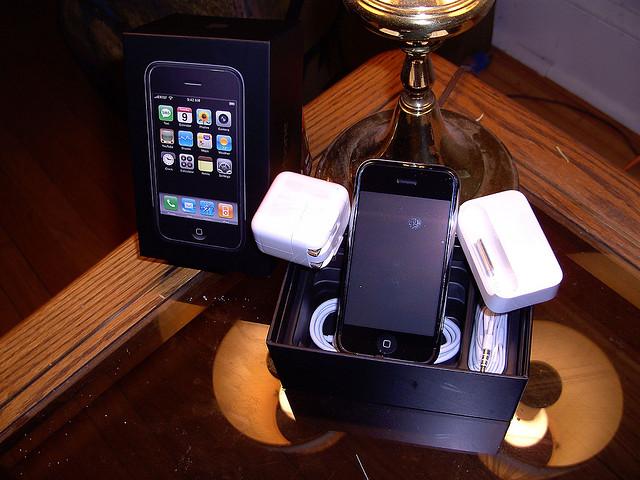Is one phone on?
Give a very brief answer. Yes. What brand of phone is this?
Write a very short answer. Iphone. Are both phones in a box?
Answer briefly. No. 